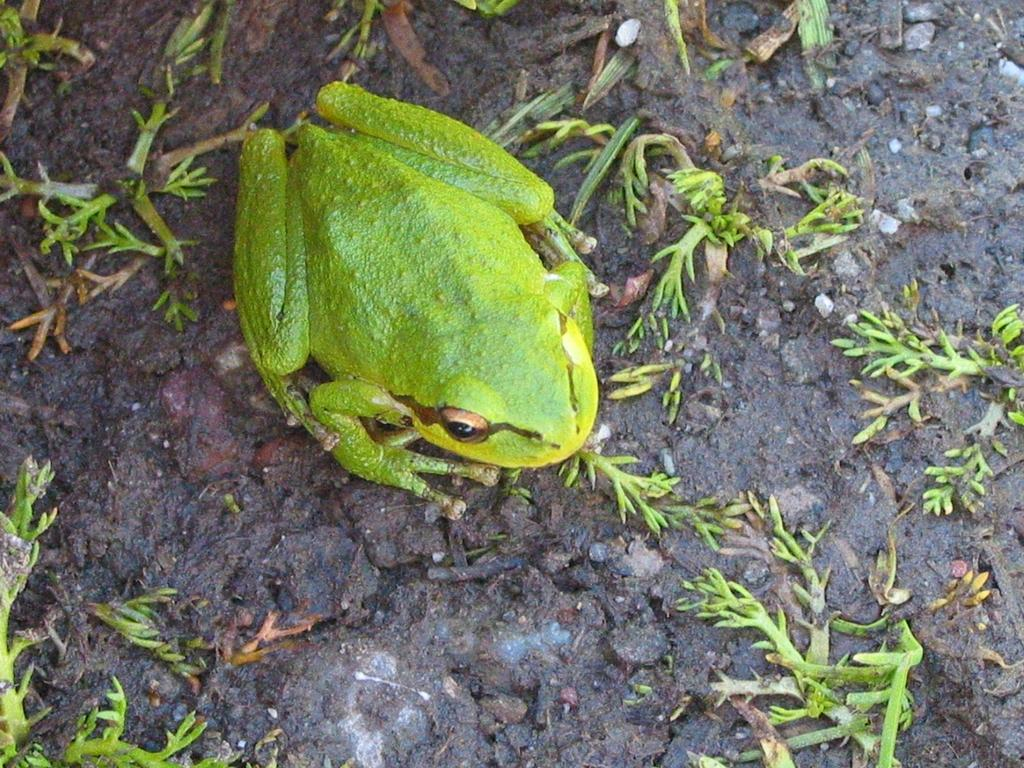What type of animal is present in the image? There is a frog in the image. What type of cord is used to connect the downtown area to the heat source in the image? There is no downtown area, heat source, or cord present in the image; it only features a frog. 